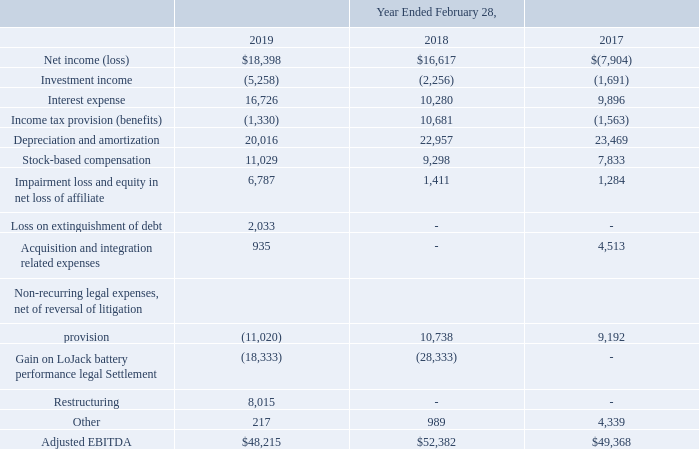Our CODM evaluates each segment based on Adjusted Earnings Before Interest, Taxes, Depreciation and Amortization (“Adjusted EBITDA”), and we therefore consider Adjusted EBITDA to be a primary measure of operating performance of our operating segments. We define Adjusted EBITDA as earnings before investment income, interest expense, taxes, depreciation, amortization and stock-based compensation and other adjustments as identified below. The adjustments to our financial results prepared in accordance with U.S. generally accepted accounting principles (“GAAP”) to calculate Adjusted EBITDA are itemized below (in thousands):
It is not practicable for us to report identifiable assets by segment because these businesses share resources, functions and facilities
We do not have significant long-lived assets outside the United States.
Why is it not practicable to report identifiable assets by segment? Because these businesses share resources, functions and facilities. What was the loss on extinguishment of debt in 2019?
Answer scale should be: thousand. 2,033. How much was restructuring in 2019?
Answer scale should be: thousand. 8,015. What was the change in interest expense between 2017 and 2018?
Answer scale should be: thousand. (10,280-9,896)
Answer: 384. What was the change in stock-based compensation between 2018 and 2019?
Answer scale should be: thousand. (11,029-9,298)
Answer: 1731. What was the percentage change in Depreciation and amortization between 2017 and 2018?
Answer scale should be: percent. (22,957-23,469)/23,469
Answer: -2.18. 